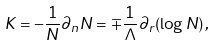Convert formula to latex. <formula><loc_0><loc_0><loc_500><loc_500>K = - \frac { 1 } { N } \partial _ { n } N = \mp \frac { 1 } { \Lambda } \partial _ { r } ( \log N ) \, ,</formula> 